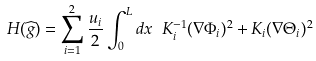Convert formula to latex. <formula><loc_0><loc_0><loc_500><loc_500>H ( \widehat { g } ) = \sum _ { i = 1 } ^ { 2 } \frac { u _ { i } } { 2 } \int _ { 0 } ^ { L } d x \ K _ { i } ^ { - 1 } ( \nabla \Phi _ { i } ) ^ { 2 } + K _ { i } ( \nabla \Theta _ { i } ) ^ { 2 }</formula> 